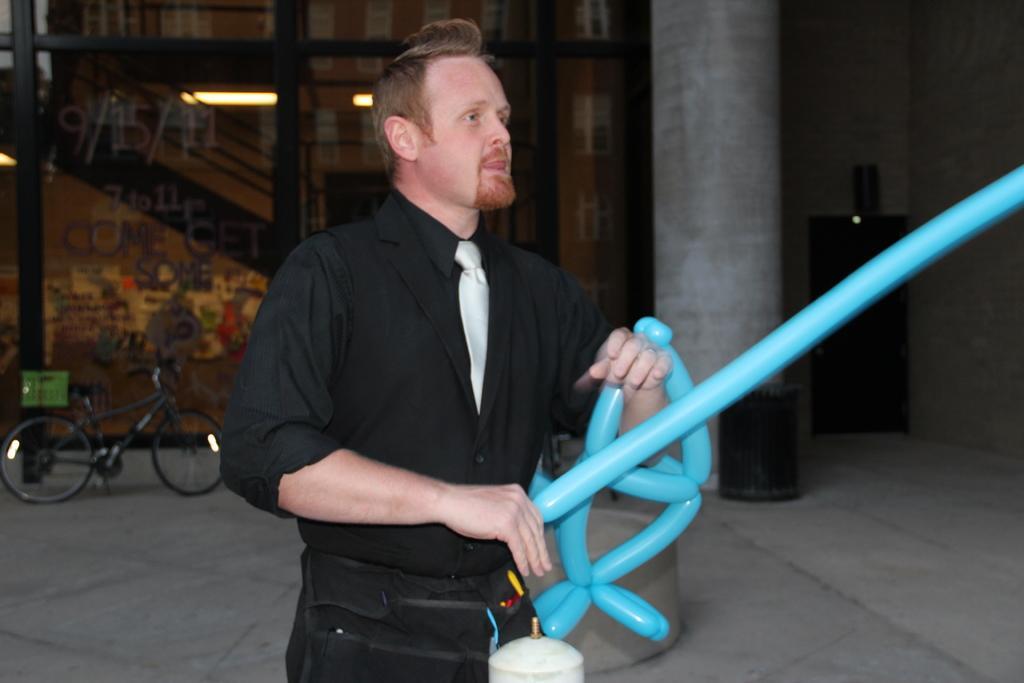Describe this image in one or two sentences. In this picture I can see a man standing in front and I see that he is wearing formal dress and I can also see that he is holding blue color balloons. In the background I can see the path on which there is a cycle and few black color things and I can also see a pillar and I can see the lights in the building. 